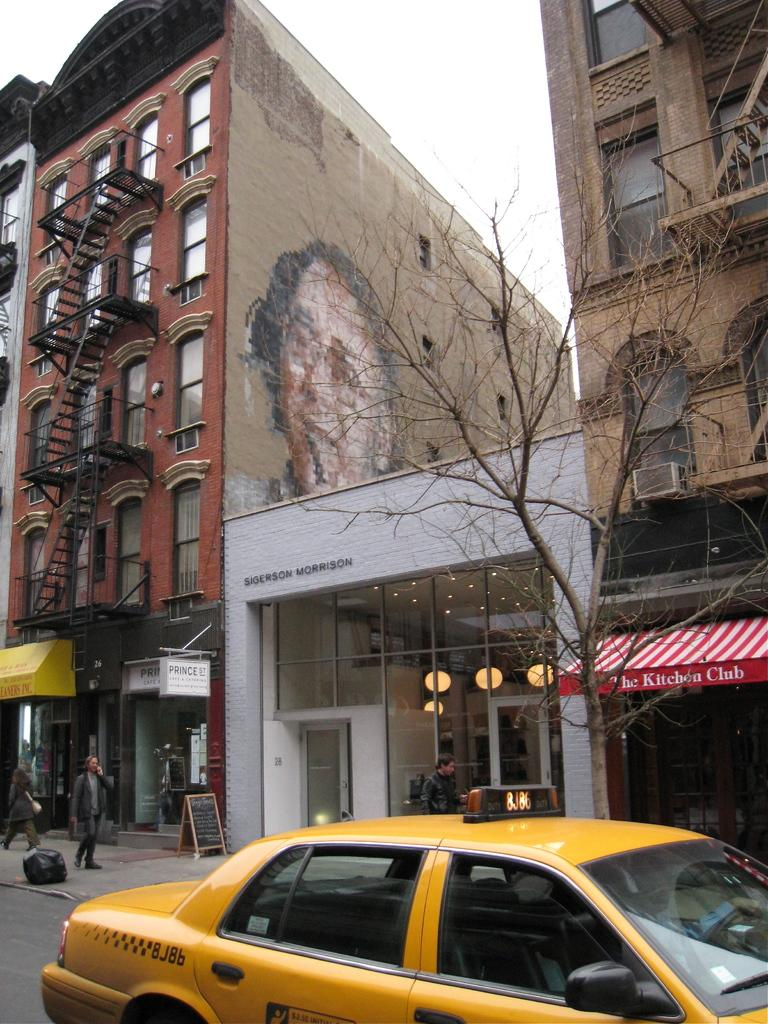<image>
Share a concise interpretation of the image provided. The Sigerson Morrison building stands out given it is a one story white building among multi-story red and brown buildings. 